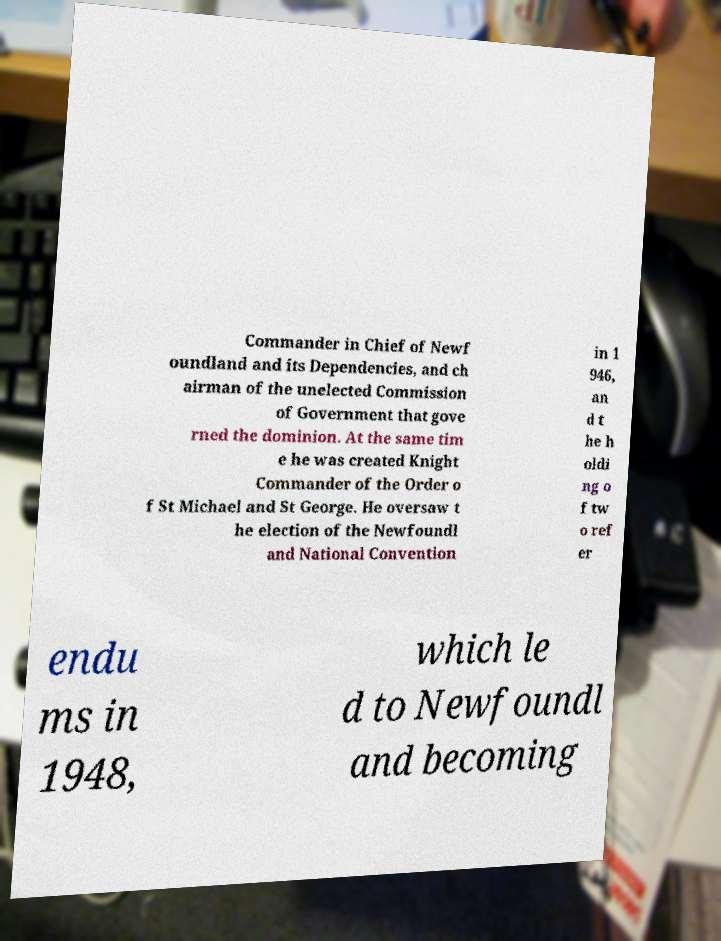Can you accurately transcribe the text from the provided image for me? Commander in Chief of Newf oundland and its Dependencies, and ch airman of the unelected Commission of Government that gove rned the dominion. At the same tim e he was created Knight Commander of the Order o f St Michael and St George. He oversaw t he election of the Newfoundl and National Convention in 1 946, an d t he h oldi ng o f tw o ref er endu ms in 1948, which le d to Newfoundl and becoming 